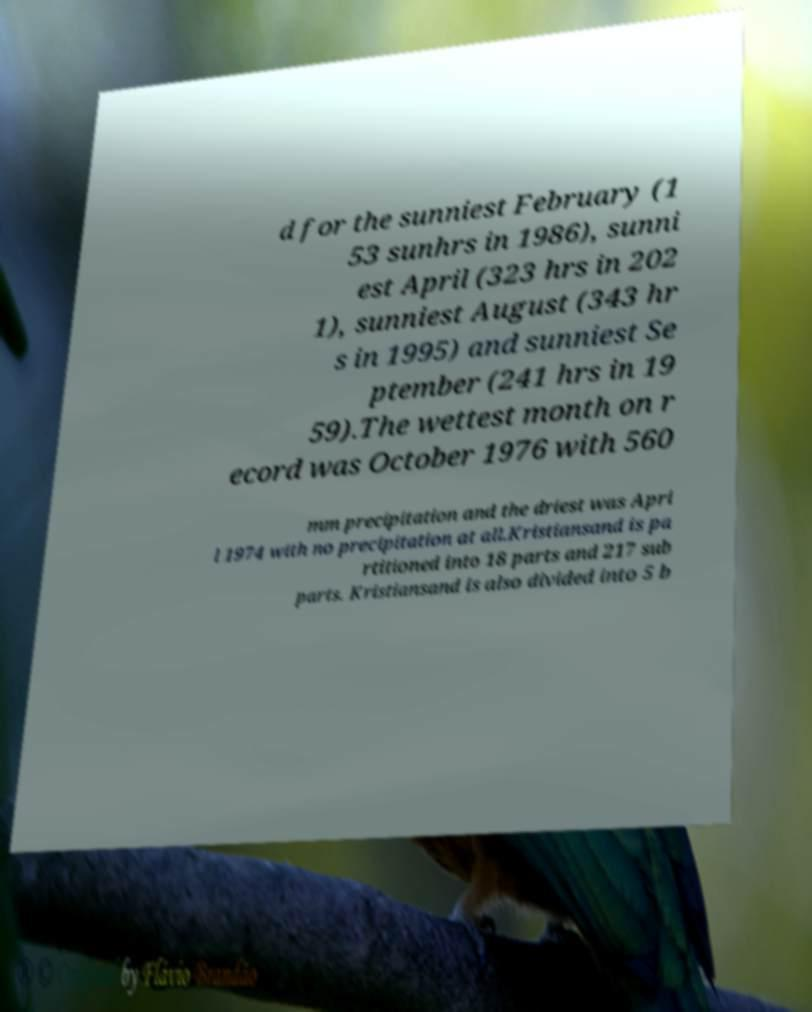For documentation purposes, I need the text within this image transcribed. Could you provide that? d for the sunniest February (1 53 sunhrs in 1986), sunni est April (323 hrs in 202 1), sunniest August (343 hr s in 1995) and sunniest Se ptember (241 hrs in 19 59).The wettest month on r ecord was October 1976 with 560 mm precipitation and the driest was Apri l 1974 with no precipitation at all.Kristiansand is pa rtitioned into 18 parts and 217 sub parts. Kristiansand is also divided into 5 b 